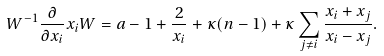<formula> <loc_0><loc_0><loc_500><loc_500>W ^ { - 1 } \frac { \partial } { \partial x _ { i } } x _ { i } W = a - 1 + \frac { 2 } { x _ { i } } + \kappa ( n - 1 ) + \kappa \sum _ { j \neq i } \frac { x _ { i } + x _ { j } } { x _ { i } - x _ { j } } .</formula> 